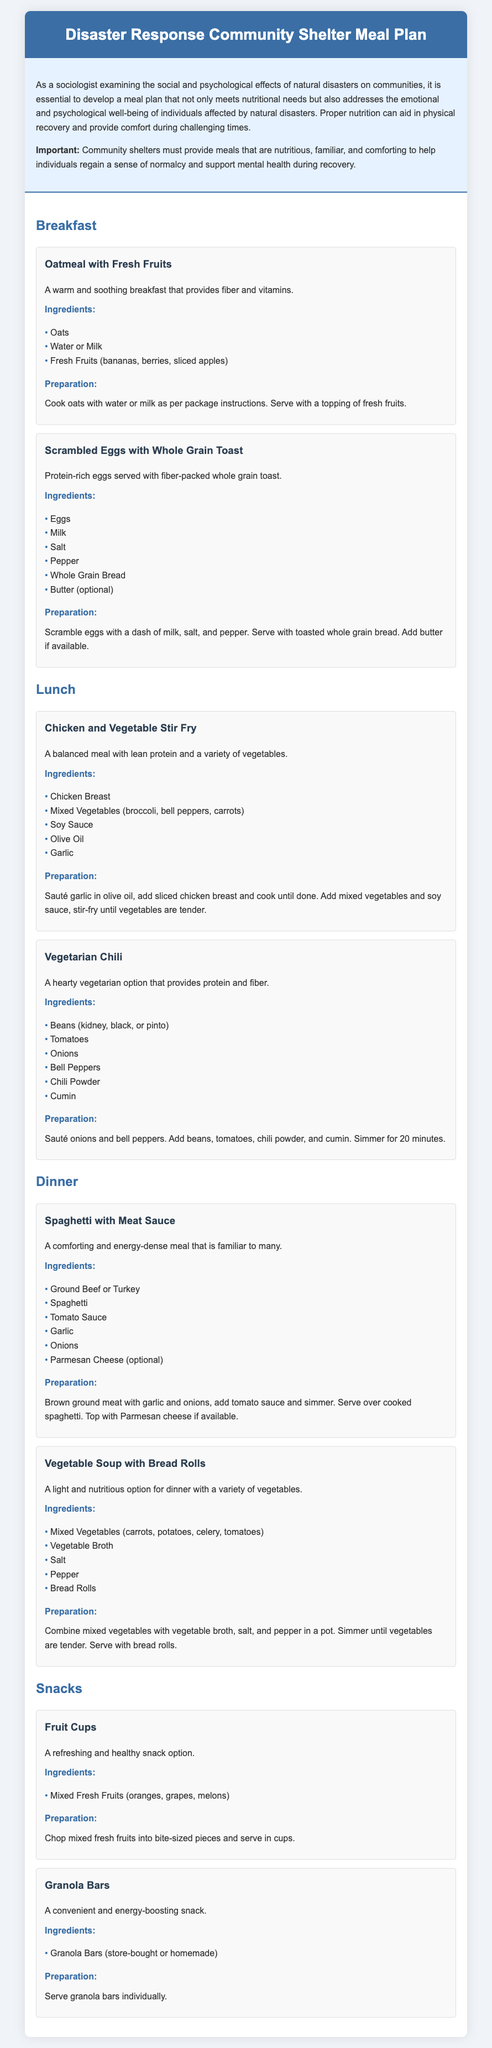What are the three main meals included in the meal plan? The document lists Breakfast, Lunch, and Dinner as the main meal types.
Answer: Breakfast, Lunch, Dinner What is the first breakfast recipe mentioned? The first recipe listed under breakfast is Oatmeal with Fresh Fruits.
Answer: Oatmeal with Fresh Fruits How many ingredients are needed for the Vegetarian Chili? The recipe for Vegetarian Chili includes six ingredients listed.
Answer: Six What is the preparation time for the Chicken and Vegetable Stir Fry? The document does not specify a preparation time for this recipe; additional context may be needed.
Answer: Not specified Which dinner recipe is vegetarian? The Vegetable Soup with Bread Rolls is the vegetarian option for dinner.
Answer: Vegetable Soup with Bread Rolls What common ingredient is found in both the breakfast and lunch recipes? The ingredient eggs is used in the breakfast recipe and is not relevant to any lunch recipe, whereas beans in Vegetarian Chili has no relevance to breakfast. Therefore, the common ingredient in the requested context is not present but the structures parallel to both meal types could be further explored.
Answer: None What is served with the Spaghetti with Meat Sauce? The recipe for Spaghetti with Meat Sauce includes a topping of Parmesan Cheese as an optional addition.
Answer: Parmesan Cheese (optional) How are the fruit cups prepared? The preparation mentions chopping mixed fresh fruits into bite-sized pieces and serving in cups.
Answer: Chop mixed fresh fruits into bite-sized pieces and serve in cups 